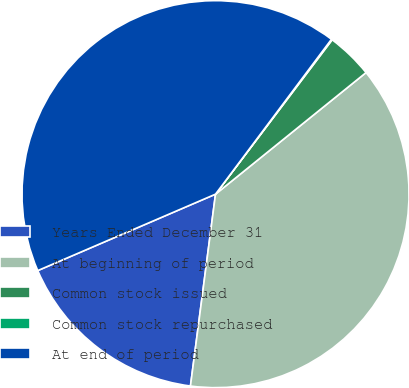<chart> <loc_0><loc_0><loc_500><loc_500><pie_chart><fcel>Years Ended December 31<fcel>At beginning of period<fcel>Common stock issued<fcel>Common stock repurchased<fcel>At end of period<nl><fcel>16.47%<fcel>37.88%<fcel>3.89%<fcel>0.07%<fcel>41.69%<nl></chart> 